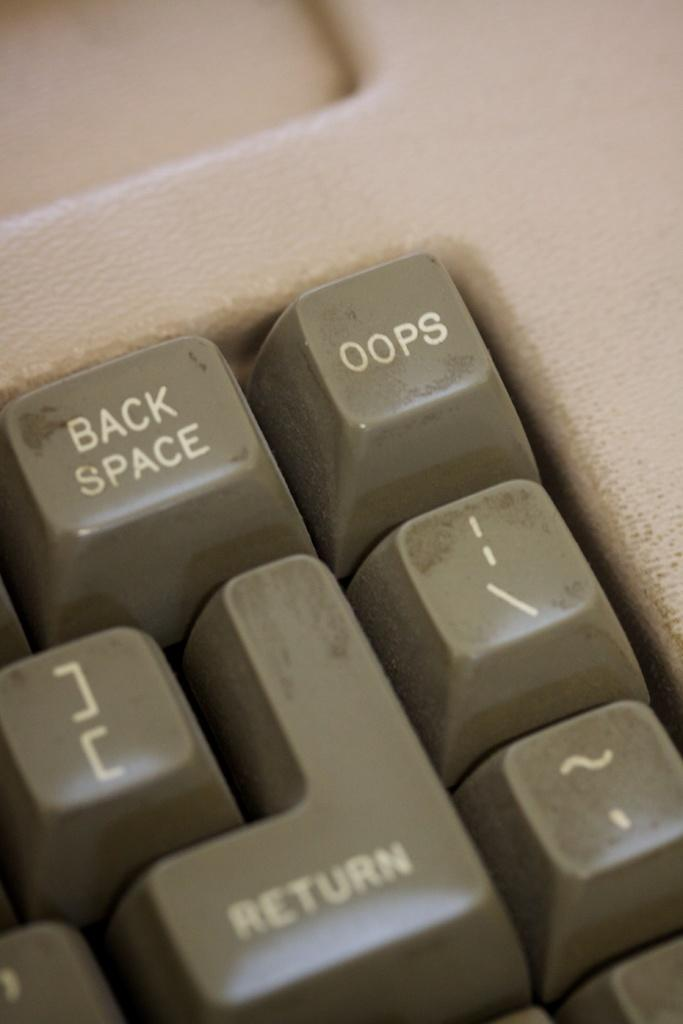<image>
Render a clear and concise summary of the photo. Keyboard keys with the one on the top right saying OOPS. 